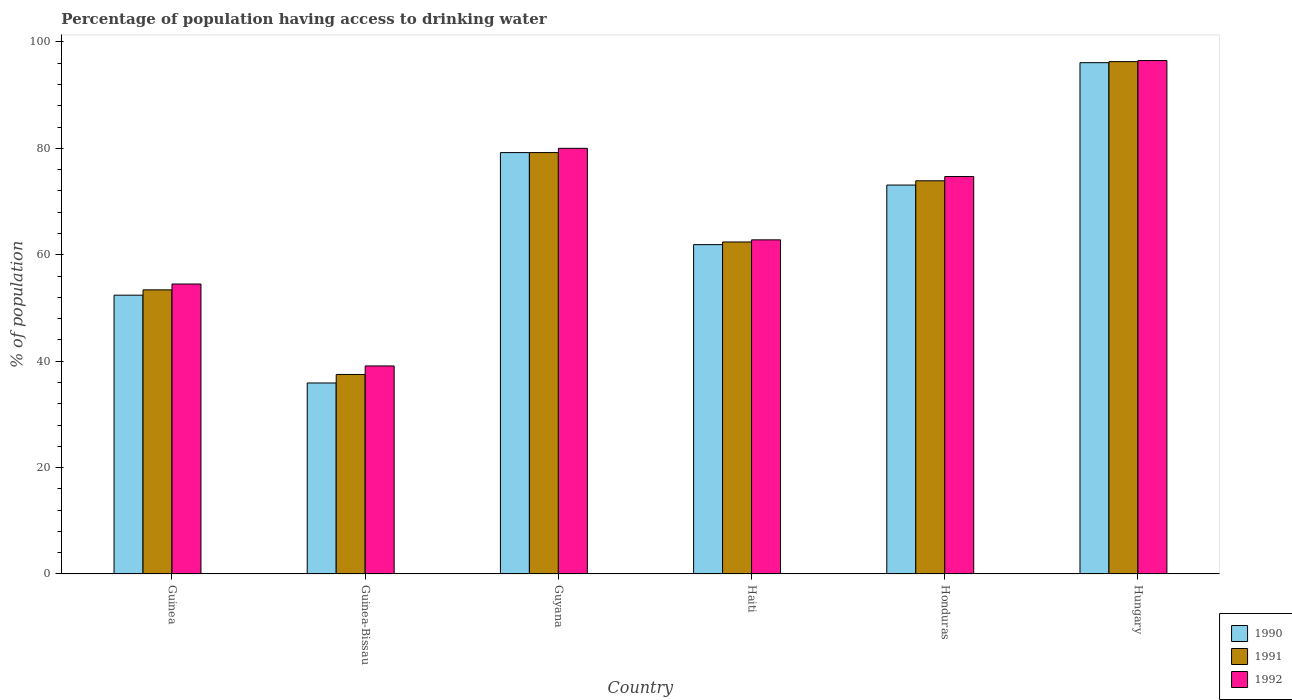How many groups of bars are there?
Provide a short and direct response. 6. Are the number of bars on each tick of the X-axis equal?
Provide a short and direct response. Yes. What is the label of the 6th group of bars from the left?
Offer a terse response. Hungary. In how many cases, is the number of bars for a given country not equal to the number of legend labels?
Offer a very short reply. 0. What is the percentage of population having access to drinking water in 1991 in Haiti?
Your response must be concise. 62.4. Across all countries, what is the maximum percentage of population having access to drinking water in 1991?
Your answer should be very brief. 96.3. Across all countries, what is the minimum percentage of population having access to drinking water in 1990?
Ensure brevity in your answer.  35.9. In which country was the percentage of population having access to drinking water in 1992 maximum?
Give a very brief answer. Hungary. In which country was the percentage of population having access to drinking water in 1990 minimum?
Give a very brief answer. Guinea-Bissau. What is the total percentage of population having access to drinking water in 1991 in the graph?
Your answer should be very brief. 402.7. What is the difference between the percentage of population having access to drinking water in 1992 in Haiti and that in Honduras?
Offer a terse response. -11.9. What is the difference between the percentage of population having access to drinking water in 1990 in Guinea-Bissau and the percentage of population having access to drinking water in 1992 in Hungary?
Make the answer very short. -60.6. What is the average percentage of population having access to drinking water in 1990 per country?
Provide a succinct answer. 66.43. What is the difference between the percentage of population having access to drinking water of/in 1991 and percentage of population having access to drinking water of/in 1990 in Haiti?
Your response must be concise. 0.5. What is the ratio of the percentage of population having access to drinking water in 1990 in Guinea to that in Guyana?
Your response must be concise. 0.66. Is the percentage of population having access to drinking water in 1990 in Guyana less than that in Haiti?
Your response must be concise. No. What is the difference between the highest and the second highest percentage of population having access to drinking water in 1991?
Your answer should be very brief. 22.4. What is the difference between the highest and the lowest percentage of population having access to drinking water in 1990?
Provide a short and direct response. 60.2. What does the 1st bar from the left in Haiti represents?
Offer a very short reply. 1990. Is it the case that in every country, the sum of the percentage of population having access to drinking water in 1991 and percentage of population having access to drinking water in 1992 is greater than the percentage of population having access to drinking water in 1990?
Your answer should be compact. Yes. How many countries are there in the graph?
Ensure brevity in your answer.  6. What is the difference between two consecutive major ticks on the Y-axis?
Your response must be concise. 20. Does the graph contain grids?
Give a very brief answer. No. How many legend labels are there?
Your response must be concise. 3. How are the legend labels stacked?
Provide a short and direct response. Vertical. What is the title of the graph?
Your answer should be very brief. Percentage of population having access to drinking water. Does "1984" appear as one of the legend labels in the graph?
Offer a very short reply. No. What is the label or title of the Y-axis?
Provide a succinct answer. % of population. What is the % of population in 1990 in Guinea?
Give a very brief answer. 52.4. What is the % of population of 1991 in Guinea?
Offer a very short reply. 53.4. What is the % of population of 1992 in Guinea?
Give a very brief answer. 54.5. What is the % of population in 1990 in Guinea-Bissau?
Offer a very short reply. 35.9. What is the % of population of 1991 in Guinea-Bissau?
Keep it short and to the point. 37.5. What is the % of population in 1992 in Guinea-Bissau?
Make the answer very short. 39.1. What is the % of population in 1990 in Guyana?
Your response must be concise. 79.2. What is the % of population of 1991 in Guyana?
Keep it short and to the point. 79.2. What is the % of population of 1990 in Haiti?
Your answer should be compact. 61.9. What is the % of population of 1991 in Haiti?
Offer a very short reply. 62.4. What is the % of population of 1992 in Haiti?
Offer a very short reply. 62.8. What is the % of population in 1990 in Honduras?
Keep it short and to the point. 73.1. What is the % of population in 1991 in Honduras?
Provide a short and direct response. 73.9. What is the % of population of 1992 in Honduras?
Your response must be concise. 74.7. What is the % of population of 1990 in Hungary?
Your response must be concise. 96.1. What is the % of population in 1991 in Hungary?
Your response must be concise. 96.3. What is the % of population of 1992 in Hungary?
Offer a terse response. 96.5. Across all countries, what is the maximum % of population of 1990?
Provide a short and direct response. 96.1. Across all countries, what is the maximum % of population of 1991?
Your answer should be very brief. 96.3. Across all countries, what is the maximum % of population of 1992?
Provide a short and direct response. 96.5. Across all countries, what is the minimum % of population of 1990?
Your answer should be compact. 35.9. Across all countries, what is the minimum % of population in 1991?
Your answer should be very brief. 37.5. Across all countries, what is the minimum % of population of 1992?
Your response must be concise. 39.1. What is the total % of population in 1990 in the graph?
Offer a terse response. 398.6. What is the total % of population of 1991 in the graph?
Your answer should be very brief. 402.7. What is the total % of population in 1992 in the graph?
Provide a short and direct response. 407.6. What is the difference between the % of population in 1990 in Guinea and that in Guyana?
Give a very brief answer. -26.8. What is the difference between the % of population of 1991 in Guinea and that in Guyana?
Your response must be concise. -25.8. What is the difference between the % of population in 1992 in Guinea and that in Guyana?
Offer a terse response. -25.5. What is the difference between the % of population of 1990 in Guinea and that in Haiti?
Provide a succinct answer. -9.5. What is the difference between the % of population in 1990 in Guinea and that in Honduras?
Offer a terse response. -20.7. What is the difference between the % of population in 1991 in Guinea and that in Honduras?
Offer a terse response. -20.5. What is the difference between the % of population in 1992 in Guinea and that in Honduras?
Your answer should be very brief. -20.2. What is the difference between the % of population of 1990 in Guinea and that in Hungary?
Your answer should be compact. -43.7. What is the difference between the % of population of 1991 in Guinea and that in Hungary?
Give a very brief answer. -42.9. What is the difference between the % of population in 1992 in Guinea and that in Hungary?
Your answer should be compact. -42. What is the difference between the % of population of 1990 in Guinea-Bissau and that in Guyana?
Provide a succinct answer. -43.3. What is the difference between the % of population of 1991 in Guinea-Bissau and that in Guyana?
Provide a short and direct response. -41.7. What is the difference between the % of population of 1992 in Guinea-Bissau and that in Guyana?
Provide a succinct answer. -40.9. What is the difference between the % of population in 1991 in Guinea-Bissau and that in Haiti?
Offer a very short reply. -24.9. What is the difference between the % of population in 1992 in Guinea-Bissau and that in Haiti?
Your answer should be compact. -23.7. What is the difference between the % of population of 1990 in Guinea-Bissau and that in Honduras?
Keep it short and to the point. -37.2. What is the difference between the % of population of 1991 in Guinea-Bissau and that in Honduras?
Your answer should be compact. -36.4. What is the difference between the % of population of 1992 in Guinea-Bissau and that in Honduras?
Provide a succinct answer. -35.6. What is the difference between the % of population of 1990 in Guinea-Bissau and that in Hungary?
Make the answer very short. -60.2. What is the difference between the % of population of 1991 in Guinea-Bissau and that in Hungary?
Provide a succinct answer. -58.8. What is the difference between the % of population of 1992 in Guinea-Bissau and that in Hungary?
Ensure brevity in your answer.  -57.4. What is the difference between the % of population of 1991 in Guyana and that in Haiti?
Make the answer very short. 16.8. What is the difference between the % of population of 1992 in Guyana and that in Haiti?
Give a very brief answer. 17.2. What is the difference between the % of population in 1990 in Guyana and that in Hungary?
Your response must be concise. -16.9. What is the difference between the % of population of 1991 in Guyana and that in Hungary?
Offer a very short reply. -17.1. What is the difference between the % of population in 1992 in Guyana and that in Hungary?
Offer a very short reply. -16.5. What is the difference between the % of population in 1990 in Haiti and that in Honduras?
Keep it short and to the point. -11.2. What is the difference between the % of population of 1992 in Haiti and that in Honduras?
Provide a short and direct response. -11.9. What is the difference between the % of population in 1990 in Haiti and that in Hungary?
Provide a succinct answer. -34.2. What is the difference between the % of population of 1991 in Haiti and that in Hungary?
Provide a short and direct response. -33.9. What is the difference between the % of population of 1992 in Haiti and that in Hungary?
Give a very brief answer. -33.7. What is the difference between the % of population of 1990 in Honduras and that in Hungary?
Offer a very short reply. -23. What is the difference between the % of population of 1991 in Honduras and that in Hungary?
Ensure brevity in your answer.  -22.4. What is the difference between the % of population in 1992 in Honduras and that in Hungary?
Give a very brief answer. -21.8. What is the difference between the % of population of 1990 in Guinea and the % of population of 1991 in Guinea-Bissau?
Your answer should be compact. 14.9. What is the difference between the % of population of 1990 in Guinea and the % of population of 1991 in Guyana?
Your answer should be compact. -26.8. What is the difference between the % of population in 1990 in Guinea and the % of population in 1992 in Guyana?
Your response must be concise. -27.6. What is the difference between the % of population in 1991 in Guinea and the % of population in 1992 in Guyana?
Offer a very short reply. -26.6. What is the difference between the % of population of 1990 in Guinea and the % of population of 1992 in Haiti?
Your response must be concise. -10.4. What is the difference between the % of population of 1990 in Guinea and the % of population of 1991 in Honduras?
Give a very brief answer. -21.5. What is the difference between the % of population in 1990 in Guinea and the % of population in 1992 in Honduras?
Make the answer very short. -22.3. What is the difference between the % of population in 1991 in Guinea and the % of population in 1992 in Honduras?
Your answer should be very brief. -21.3. What is the difference between the % of population in 1990 in Guinea and the % of population in 1991 in Hungary?
Provide a succinct answer. -43.9. What is the difference between the % of population in 1990 in Guinea and the % of population in 1992 in Hungary?
Your response must be concise. -44.1. What is the difference between the % of population of 1991 in Guinea and the % of population of 1992 in Hungary?
Your answer should be very brief. -43.1. What is the difference between the % of population of 1990 in Guinea-Bissau and the % of population of 1991 in Guyana?
Give a very brief answer. -43.3. What is the difference between the % of population of 1990 in Guinea-Bissau and the % of population of 1992 in Guyana?
Ensure brevity in your answer.  -44.1. What is the difference between the % of population in 1991 in Guinea-Bissau and the % of population in 1992 in Guyana?
Keep it short and to the point. -42.5. What is the difference between the % of population in 1990 in Guinea-Bissau and the % of population in 1991 in Haiti?
Your response must be concise. -26.5. What is the difference between the % of population in 1990 in Guinea-Bissau and the % of population in 1992 in Haiti?
Your answer should be compact. -26.9. What is the difference between the % of population of 1991 in Guinea-Bissau and the % of population of 1992 in Haiti?
Make the answer very short. -25.3. What is the difference between the % of population in 1990 in Guinea-Bissau and the % of population in 1991 in Honduras?
Keep it short and to the point. -38. What is the difference between the % of population of 1990 in Guinea-Bissau and the % of population of 1992 in Honduras?
Provide a short and direct response. -38.8. What is the difference between the % of population of 1991 in Guinea-Bissau and the % of population of 1992 in Honduras?
Give a very brief answer. -37.2. What is the difference between the % of population in 1990 in Guinea-Bissau and the % of population in 1991 in Hungary?
Your answer should be compact. -60.4. What is the difference between the % of population of 1990 in Guinea-Bissau and the % of population of 1992 in Hungary?
Provide a succinct answer. -60.6. What is the difference between the % of population of 1991 in Guinea-Bissau and the % of population of 1992 in Hungary?
Your answer should be compact. -59. What is the difference between the % of population of 1991 in Guyana and the % of population of 1992 in Haiti?
Keep it short and to the point. 16.4. What is the difference between the % of population of 1990 in Guyana and the % of population of 1991 in Honduras?
Offer a terse response. 5.3. What is the difference between the % of population of 1990 in Guyana and the % of population of 1991 in Hungary?
Offer a very short reply. -17.1. What is the difference between the % of population of 1990 in Guyana and the % of population of 1992 in Hungary?
Your answer should be compact. -17.3. What is the difference between the % of population of 1991 in Guyana and the % of population of 1992 in Hungary?
Give a very brief answer. -17.3. What is the difference between the % of population of 1990 in Haiti and the % of population of 1991 in Honduras?
Give a very brief answer. -12. What is the difference between the % of population of 1990 in Haiti and the % of population of 1992 in Honduras?
Make the answer very short. -12.8. What is the difference between the % of population in 1990 in Haiti and the % of population in 1991 in Hungary?
Give a very brief answer. -34.4. What is the difference between the % of population of 1990 in Haiti and the % of population of 1992 in Hungary?
Keep it short and to the point. -34.6. What is the difference between the % of population in 1991 in Haiti and the % of population in 1992 in Hungary?
Provide a succinct answer. -34.1. What is the difference between the % of population in 1990 in Honduras and the % of population in 1991 in Hungary?
Give a very brief answer. -23.2. What is the difference between the % of population of 1990 in Honduras and the % of population of 1992 in Hungary?
Your response must be concise. -23.4. What is the difference between the % of population of 1991 in Honduras and the % of population of 1992 in Hungary?
Offer a terse response. -22.6. What is the average % of population in 1990 per country?
Provide a short and direct response. 66.43. What is the average % of population in 1991 per country?
Offer a very short reply. 67.12. What is the average % of population of 1992 per country?
Keep it short and to the point. 67.93. What is the difference between the % of population of 1990 and % of population of 1991 in Guinea?
Your answer should be very brief. -1. What is the difference between the % of population in 1990 and % of population in 1992 in Guinea-Bissau?
Your answer should be compact. -3.2. What is the difference between the % of population of 1991 and % of population of 1992 in Guinea-Bissau?
Keep it short and to the point. -1.6. What is the difference between the % of population of 1990 and % of population of 1991 in Guyana?
Provide a short and direct response. 0. What is the difference between the % of population of 1991 and % of population of 1992 in Guyana?
Ensure brevity in your answer.  -0.8. What is the difference between the % of population of 1990 and % of population of 1992 in Haiti?
Your answer should be compact. -0.9. What is the ratio of the % of population in 1990 in Guinea to that in Guinea-Bissau?
Provide a succinct answer. 1.46. What is the ratio of the % of population in 1991 in Guinea to that in Guinea-Bissau?
Offer a terse response. 1.42. What is the ratio of the % of population in 1992 in Guinea to that in Guinea-Bissau?
Give a very brief answer. 1.39. What is the ratio of the % of population in 1990 in Guinea to that in Guyana?
Offer a terse response. 0.66. What is the ratio of the % of population of 1991 in Guinea to that in Guyana?
Provide a succinct answer. 0.67. What is the ratio of the % of population in 1992 in Guinea to that in Guyana?
Give a very brief answer. 0.68. What is the ratio of the % of population in 1990 in Guinea to that in Haiti?
Provide a short and direct response. 0.85. What is the ratio of the % of population of 1991 in Guinea to that in Haiti?
Make the answer very short. 0.86. What is the ratio of the % of population of 1992 in Guinea to that in Haiti?
Make the answer very short. 0.87. What is the ratio of the % of population of 1990 in Guinea to that in Honduras?
Make the answer very short. 0.72. What is the ratio of the % of population in 1991 in Guinea to that in Honduras?
Provide a succinct answer. 0.72. What is the ratio of the % of population of 1992 in Guinea to that in Honduras?
Your response must be concise. 0.73. What is the ratio of the % of population of 1990 in Guinea to that in Hungary?
Provide a short and direct response. 0.55. What is the ratio of the % of population in 1991 in Guinea to that in Hungary?
Provide a short and direct response. 0.55. What is the ratio of the % of population of 1992 in Guinea to that in Hungary?
Ensure brevity in your answer.  0.56. What is the ratio of the % of population of 1990 in Guinea-Bissau to that in Guyana?
Give a very brief answer. 0.45. What is the ratio of the % of population of 1991 in Guinea-Bissau to that in Guyana?
Your response must be concise. 0.47. What is the ratio of the % of population of 1992 in Guinea-Bissau to that in Guyana?
Provide a succinct answer. 0.49. What is the ratio of the % of population in 1990 in Guinea-Bissau to that in Haiti?
Make the answer very short. 0.58. What is the ratio of the % of population in 1991 in Guinea-Bissau to that in Haiti?
Give a very brief answer. 0.6. What is the ratio of the % of population in 1992 in Guinea-Bissau to that in Haiti?
Provide a short and direct response. 0.62. What is the ratio of the % of population in 1990 in Guinea-Bissau to that in Honduras?
Offer a very short reply. 0.49. What is the ratio of the % of population in 1991 in Guinea-Bissau to that in Honduras?
Keep it short and to the point. 0.51. What is the ratio of the % of population of 1992 in Guinea-Bissau to that in Honduras?
Your answer should be very brief. 0.52. What is the ratio of the % of population in 1990 in Guinea-Bissau to that in Hungary?
Provide a short and direct response. 0.37. What is the ratio of the % of population in 1991 in Guinea-Bissau to that in Hungary?
Your answer should be very brief. 0.39. What is the ratio of the % of population in 1992 in Guinea-Bissau to that in Hungary?
Offer a very short reply. 0.41. What is the ratio of the % of population of 1990 in Guyana to that in Haiti?
Offer a terse response. 1.28. What is the ratio of the % of population in 1991 in Guyana to that in Haiti?
Offer a very short reply. 1.27. What is the ratio of the % of population of 1992 in Guyana to that in Haiti?
Offer a terse response. 1.27. What is the ratio of the % of population in 1990 in Guyana to that in Honduras?
Make the answer very short. 1.08. What is the ratio of the % of population in 1991 in Guyana to that in Honduras?
Your answer should be compact. 1.07. What is the ratio of the % of population in 1992 in Guyana to that in Honduras?
Give a very brief answer. 1.07. What is the ratio of the % of population in 1990 in Guyana to that in Hungary?
Provide a succinct answer. 0.82. What is the ratio of the % of population of 1991 in Guyana to that in Hungary?
Make the answer very short. 0.82. What is the ratio of the % of population in 1992 in Guyana to that in Hungary?
Your answer should be compact. 0.83. What is the ratio of the % of population of 1990 in Haiti to that in Honduras?
Provide a short and direct response. 0.85. What is the ratio of the % of population of 1991 in Haiti to that in Honduras?
Ensure brevity in your answer.  0.84. What is the ratio of the % of population in 1992 in Haiti to that in Honduras?
Provide a short and direct response. 0.84. What is the ratio of the % of population in 1990 in Haiti to that in Hungary?
Ensure brevity in your answer.  0.64. What is the ratio of the % of population in 1991 in Haiti to that in Hungary?
Your answer should be very brief. 0.65. What is the ratio of the % of population in 1992 in Haiti to that in Hungary?
Keep it short and to the point. 0.65. What is the ratio of the % of population in 1990 in Honduras to that in Hungary?
Provide a short and direct response. 0.76. What is the ratio of the % of population in 1991 in Honduras to that in Hungary?
Provide a short and direct response. 0.77. What is the ratio of the % of population in 1992 in Honduras to that in Hungary?
Provide a succinct answer. 0.77. What is the difference between the highest and the second highest % of population of 1990?
Offer a very short reply. 16.9. What is the difference between the highest and the second highest % of population of 1991?
Make the answer very short. 17.1. What is the difference between the highest and the second highest % of population of 1992?
Keep it short and to the point. 16.5. What is the difference between the highest and the lowest % of population in 1990?
Provide a short and direct response. 60.2. What is the difference between the highest and the lowest % of population of 1991?
Give a very brief answer. 58.8. What is the difference between the highest and the lowest % of population of 1992?
Your response must be concise. 57.4. 